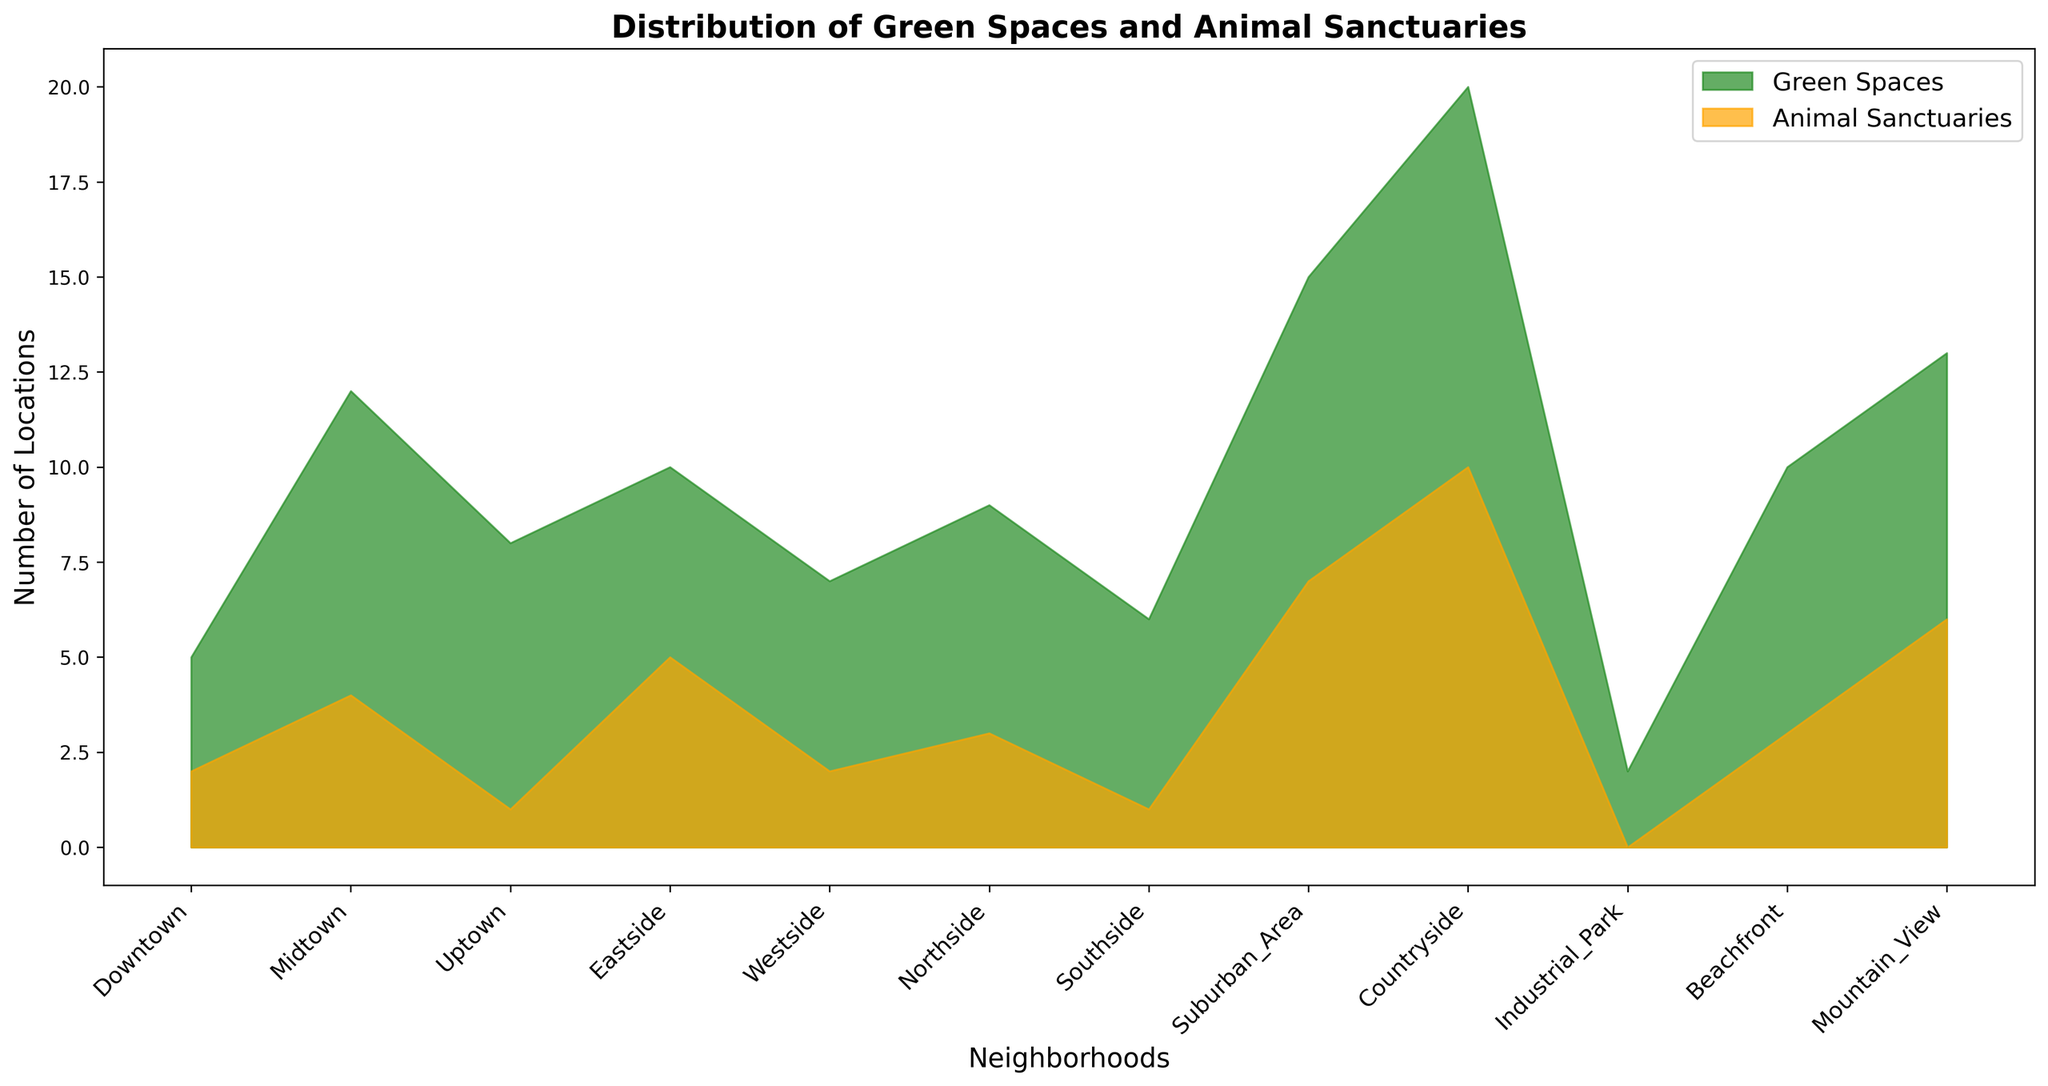Which neighborhood has the highest number of animal sanctuaries? By inspecting the area under the orange region, Countryside is the highest point.
Answer: Countryside Which neighborhood has the fewest green spaces? The smallest green area is over Industrial Park.
Answer: Industrial Park In which neighborhood is the difference between green spaces and animal sanctuaries the largest? By checking each neighborhood, the largest difference between green spaces and animal sanctuaries occurs in Countryside with 10 more green spaces than sanctuaries.
Answer: Countryside Are there any neighborhoods where the number of green spaces is the same as the number of animal sanctuaries? On the chart, it's clear that the number of green spaces is always greater than the number of animal sanctuaries in each neighborhood.
Answer: No How many green spaces and animal sanctuaries combined are there in Mountain View? Green spaces in Mountain View: 13, Animal sanctuaries: 6. So, the total is 13 + 6 = 19.
Answer: 19 Compare the number of animal sanctuaries in Downtown and Westside. Which has more and by how much? Downtown has 2 animal sanctuaries, while Westside also has 2, so the difference is 0.
Answer: Both have the same number What's the average number of green spaces across all the neighborhoods? Sum all green spaces (5+12+8+10+7+9+6+15+20+2+10+13 = 117) and divide by the number of neighborhoods (12). The average is 117 / 12 = 9.75.
Answer: 9.75 Which neighborhood has more green spaces: Eastside or Beachfront? Eastside has 10 green spaces, Beachfront has the same; thus, both are equal in this aspect.
Answer: They are equal If the number of animal sanctuaries in Northside increased by 2, how many would there be? Northside originally has 3 animal sanctuaries. With an increase of 2, the total would be 3 + 2 = 5.
Answer: 5 What is the combined number of green spaces in Downtown, Eastside, and Suburban Area? Downtown: 5, Eastside: 10, Suburban Area: 15. Their combined total is 5 + 10 + 15 = 30.
Answer: 30 